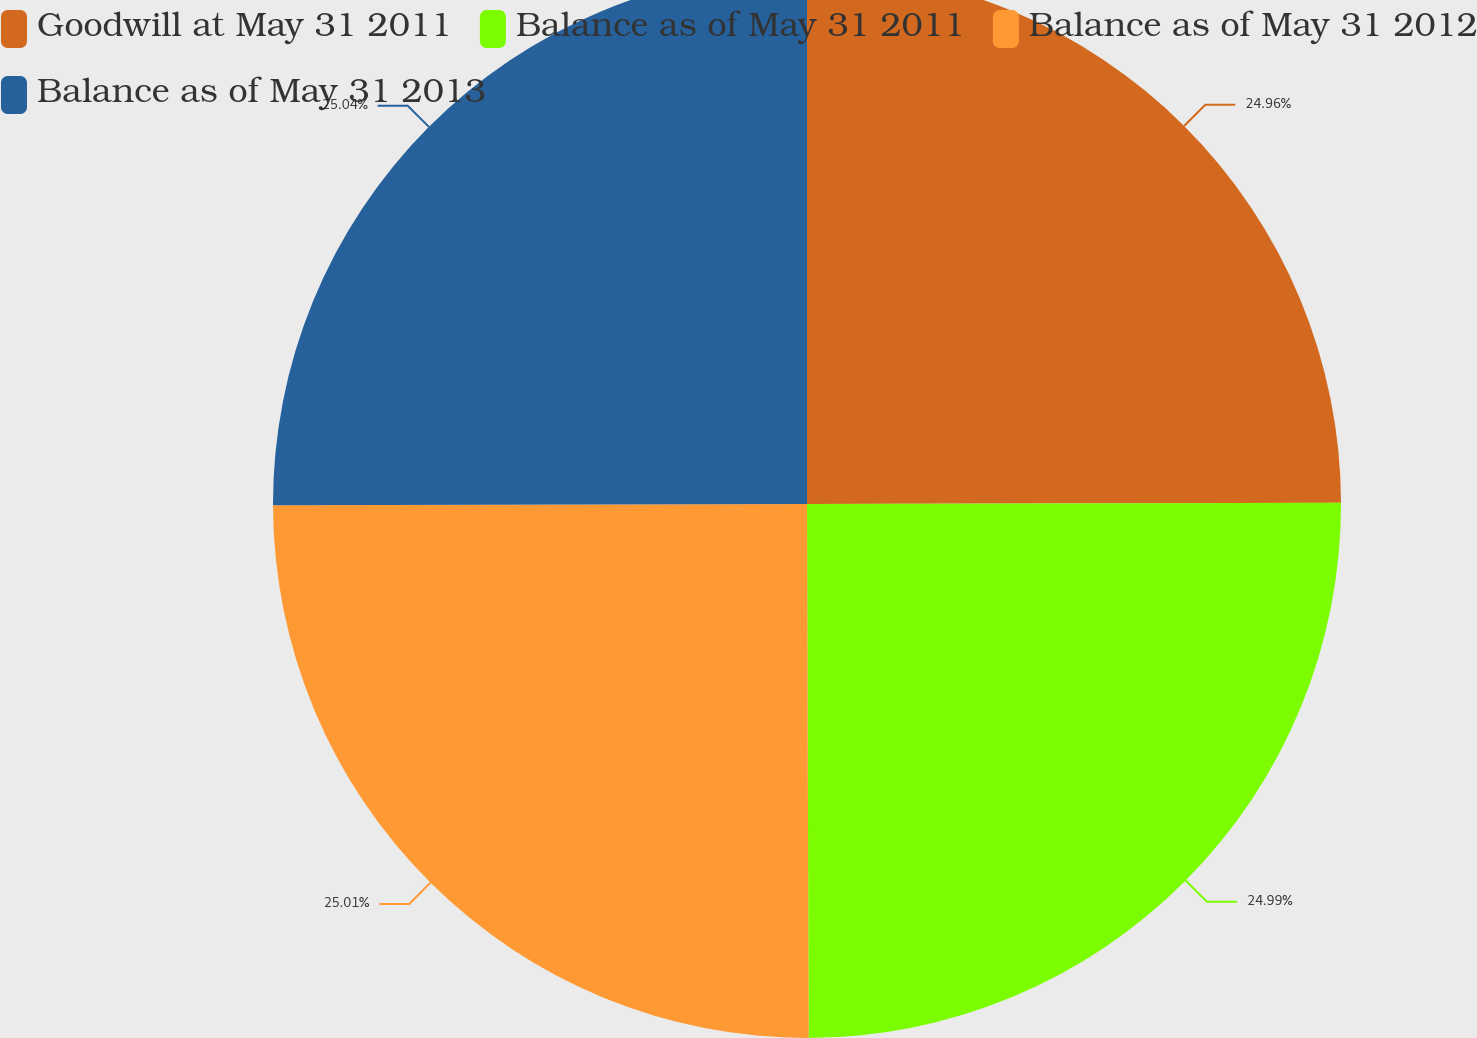Convert chart to OTSL. <chart><loc_0><loc_0><loc_500><loc_500><pie_chart><fcel>Goodwill at May 31 2011<fcel>Balance as of May 31 2011<fcel>Balance as of May 31 2012<fcel>Balance as of May 31 2013<nl><fcel>24.96%<fcel>24.99%<fcel>25.01%<fcel>25.04%<nl></chart> 